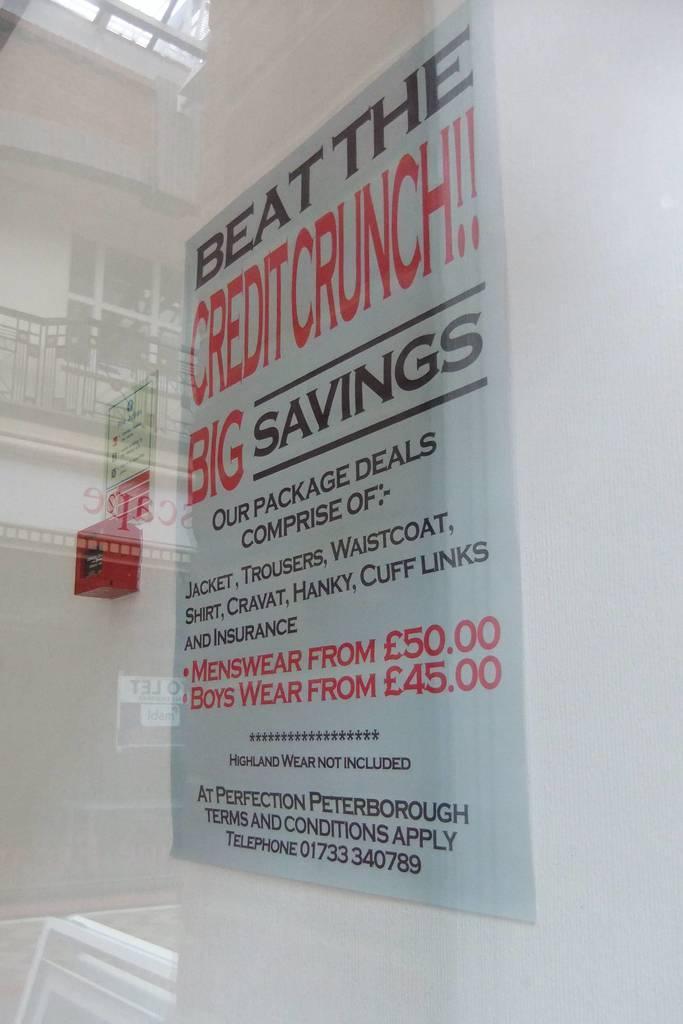Please provide a concise description of this image. In this image I can see a inner part of the building. I can see few boards and something is written on it. I can see a white wall. 